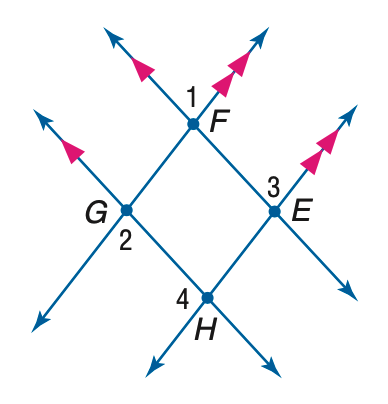Answer the mathemtical geometry problem and directly provide the correct option letter.
Question: If m \angle 1 = 3 x + 40, m \angle 2 = 2(y - 10), and m \angle 3 = 2 x + 70, find x.
Choices: A: 30 B: 40 C: 70 D: 75 A 